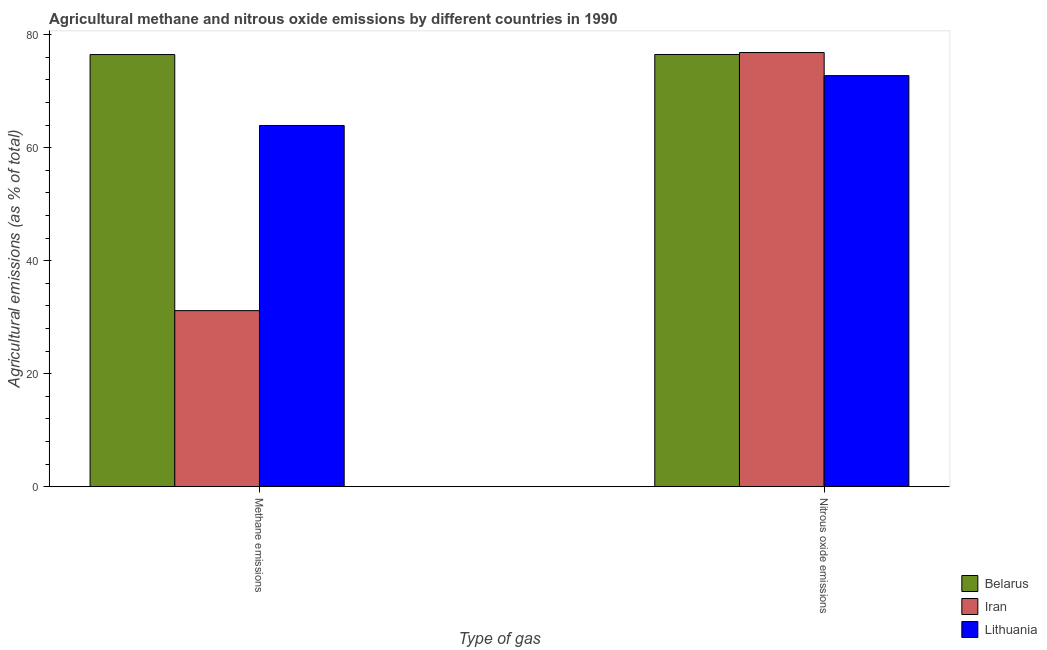Are the number of bars per tick equal to the number of legend labels?
Provide a short and direct response. Yes. Are the number of bars on each tick of the X-axis equal?
Your response must be concise. Yes. How many bars are there on the 2nd tick from the left?
Your response must be concise. 3. How many bars are there on the 2nd tick from the right?
Make the answer very short. 3. What is the label of the 1st group of bars from the left?
Your response must be concise. Methane emissions. What is the amount of nitrous oxide emissions in Iran?
Your response must be concise. 76.84. Across all countries, what is the maximum amount of nitrous oxide emissions?
Your answer should be compact. 76.84. Across all countries, what is the minimum amount of methane emissions?
Ensure brevity in your answer.  31.16. In which country was the amount of nitrous oxide emissions maximum?
Make the answer very short. Iran. In which country was the amount of nitrous oxide emissions minimum?
Ensure brevity in your answer.  Lithuania. What is the total amount of nitrous oxide emissions in the graph?
Your answer should be very brief. 226.1. What is the difference between the amount of methane emissions in Belarus and that in Iran?
Ensure brevity in your answer.  45.33. What is the difference between the amount of nitrous oxide emissions in Lithuania and the amount of methane emissions in Belarus?
Your answer should be very brief. -3.73. What is the average amount of nitrous oxide emissions per country?
Provide a succinct answer. 75.37. What is the difference between the amount of nitrous oxide emissions and amount of methane emissions in Iran?
Your answer should be very brief. 45.68. In how many countries, is the amount of methane emissions greater than 76 %?
Offer a very short reply. 1. What is the ratio of the amount of methane emissions in Belarus to that in Iran?
Your answer should be very brief. 2.45. Is the amount of methane emissions in Lithuania less than that in Iran?
Give a very brief answer. No. In how many countries, is the amount of nitrous oxide emissions greater than the average amount of nitrous oxide emissions taken over all countries?
Your response must be concise. 2. What does the 2nd bar from the left in Nitrous oxide emissions represents?
Make the answer very short. Iran. What does the 1st bar from the right in Nitrous oxide emissions represents?
Make the answer very short. Lithuania. Are all the bars in the graph horizontal?
Provide a short and direct response. No. How many countries are there in the graph?
Your response must be concise. 3. What is the difference between two consecutive major ticks on the Y-axis?
Offer a very short reply. 20. Does the graph contain any zero values?
Your answer should be compact. No. How are the legend labels stacked?
Give a very brief answer. Vertical. What is the title of the graph?
Keep it short and to the point. Agricultural methane and nitrous oxide emissions by different countries in 1990. Does "Ukraine" appear as one of the legend labels in the graph?
Offer a terse response. No. What is the label or title of the X-axis?
Give a very brief answer. Type of gas. What is the label or title of the Y-axis?
Provide a succinct answer. Agricultural emissions (as % of total). What is the Agricultural emissions (as % of total) of Belarus in Methane emissions?
Make the answer very short. 76.49. What is the Agricultural emissions (as % of total) in Iran in Methane emissions?
Your response must be concise. 31.16. What is the Agricultural emissions (as % of total) of Lithuania in Methane emissions?
Give a very brief answer. 63.93. What is the Agricultural emissions (as % of total) of Belarus in Nitrous oxide emissions?
Offer a terse response. 76.5. What is the Agricultural emissions (as % of total) in Iran in Nitrous oxide emissions?
Your response must be concise. 76.84. What is the Agricultural emissions (as % of total) of Lithuania in Nitrous oxide emissions?
Provide a succinct answer. 72.76. Across all Type of gas, what is the maximum Agricultural emissions (as % of total) of Belarus?
Ensure brevity in your answer.  76.5. Across all Type of gas, what is the maximum Agricultural emissions (as % of total) of Iran?
Provide a short and direct response. 76.84. Across all Type of gas, what is the maximum Agricultural emissions (as % of total) of Lithuania?
Make the answer very short. 72.76. Across all Type of gas, what is the minimum Agricultural emissions (as % of total) in Belarus?
Your response must be concise. 76.49. Across all Type of gas, what is the minimum Agricultural emissions (as % of total) of Iran?
Offer a terse response. 31.16. Across all Type of gas, what is the minimum Agricultural emissions (as % of total) in Lithuania?
Offer a terse response. 63.93. What is the total Agricultural emissions (as % of total) of Belarus in the graph?
Your answer should be very brief. 152.99. What is the total Agricultural emissions (as % of total) in Iran in the graph?
Your answer should be very brief. 108. What is the total Agricultural emissions (as % of total) of Lithuania in the graph?
Ensure brevity in your answer.  136.69. What is the difference between the Agricultural emissions (as % of total) in Belarus in Methane emissions and that in Nitrous oxide emissions?
Your answer should be compact. -0.01. What is the difference between the Agricultural emissions (as % of total) of Iran in Methane emissions and that in Nitrous oxide emissions?
Offer a very short reply. -45.68. What is the difference between the Agricultural emissions (as % of total) of Lithuania in Methane emissions and that in Nitrous oxide emissions?
Make the answer very short. -8.82. What is the difference between the Agricultural emissions (as % of total) of Belarus in Methane emissions and the Agricultural emissions (as % of total) of Iran in Nitrous oxide emissions?
Provide a short and direct response. -0.36. What is the difference between the Agricultural emissions (as % of total) in Belarus in Methane emissions and the Agricultural emissions (as % of total) in Lithuania in Nitrous oxide emissions?
Provide a short and direct response. 3.73. What is the difference between the Agricultural emissions (as % of total) in Iran in Methane emissions and the Agricultural emissions (as % of total) in Lithuania in Nitrous oxide emissions?
Make the answer very short. -41.6. What is the average Agricultural emissions (as % of total) of Belarus per Type of gas?
Offer a very short reply. 76.49. What is the average Agricultural emissions (as % of total) of Iran per Type of gas?
Provide a succinct answer. 54. What is the average Agricultural emissions (as % of total) in Lithuania per Type of gas?
Ensure brevity in your answer.  68.35. What is the difference between the Agricultural emissions (as % of total) in Belarus and Agricultural emissions (as % of total) in Iran in Methane emissions?
Offer a terse response. 45.33. What is the difference between the Agricultural emissions (as % of total) of Belarus and Agricultural emissions (as % of total) of Lithuania in Methane emissions?
Provide a short and direct response. 12.55. What is the difference between the Agricultural emissions (as % of total) in Iran and Agricultural emissions (as % of total) in Lithuania in Methane emissions?
Give a very brief answer. -32.77. What is the difference between the Agricultural emissions (as % of total) of Belarus and Agricultural emissions (as % of total) of Iran in Nitrous oxide emissions?
Ensure brevity in your answer.  -0.35. What is the difference between the Agricultural emissions (as % of total) in Belarus and Agricultural emissions (as % of total) in Lithuania in Nitrous oxide emissions?
Your answer should be very brief. 3.74. What is the difference between the Agricultural emissions (as % of total) in Iran and Agricultural emissions (as % of total) in Lithuania in Nitrous oxide emissions?
Offer a very short reply. 4.09. What is the ratio of the Agricultural emissions (as % of total) of Belarus in Methane emissions to that in Nitrous oxide emissions?
Provide a succinct answer. 1. What is the ratio of the Agricultural emissions (as % of total) of Iran in Methane emissions to that in Nitrous oxide emissions?
Keep it short and to the point. 0.41. What is the ratio of the Agricultural emissions (as % of total) in Lithuania in Methane emissions to that in Nitrous oxide emissions?
Make the answer very short. 0.88. What is the difference between the highest and the second highest Agricultural emissions (as % of total) in Belarus?
Make the answer very short. 0.01. What is the difference between the highest and the second highest Agricultural emissions (as % of total) in Iran?
Keep it short and to the point. 45.68. What is the difference between the highest and the second highest Agricultural emissions (as % of total) in Lithuania?
Give a very brief answer. 8.82. What is the difference between the highest and the lowest Agricultural emissions (as % of total) in Belarus?
Keep it short and to the point. 0.01. What is the difference between the highest and the lowest Agricultural emissions (as % of total) in Iran?
Make the answer very short. 45.68. What is the difference between the highest and the lowest Agricultural emissions (as % of total) of Lithuania?
Your response must be concise. 8.82. 